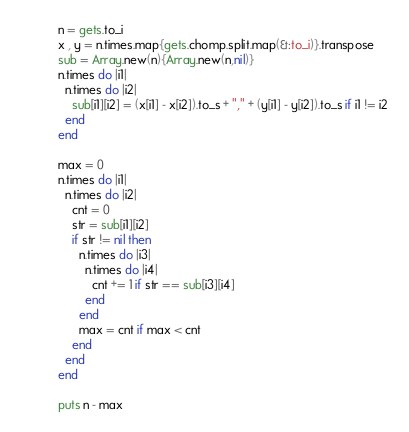Convert code to text. <code><loc_0><loc_0><loc_500><loc_500><_Ruby_>n = gets.to_i
x , y = n.times.map{gets.chomp.split.map(&:to_i)}.transpose
sub = Array.new(n){Array.new(n,nil)}
n.times do |i1|
  n.times do |i2|
    sub[i1][i2] = (x[i1] - x[i2]).to_s + "," + (y[i1] - y[i2]).to_s if i1 != i2
  end
end

max = 0
n.times do |i1|
  n.times do |i2|
    cnt = 0
    str = sub[i1][i2]
    if str != nil then
      n.times do |i3|
        n.times do |i4|
          cnt += 1 if str == sub[i3][i4]
        end
      end
      max = cnt if max < cnt
    end
  end
end

puts n - max</code> 